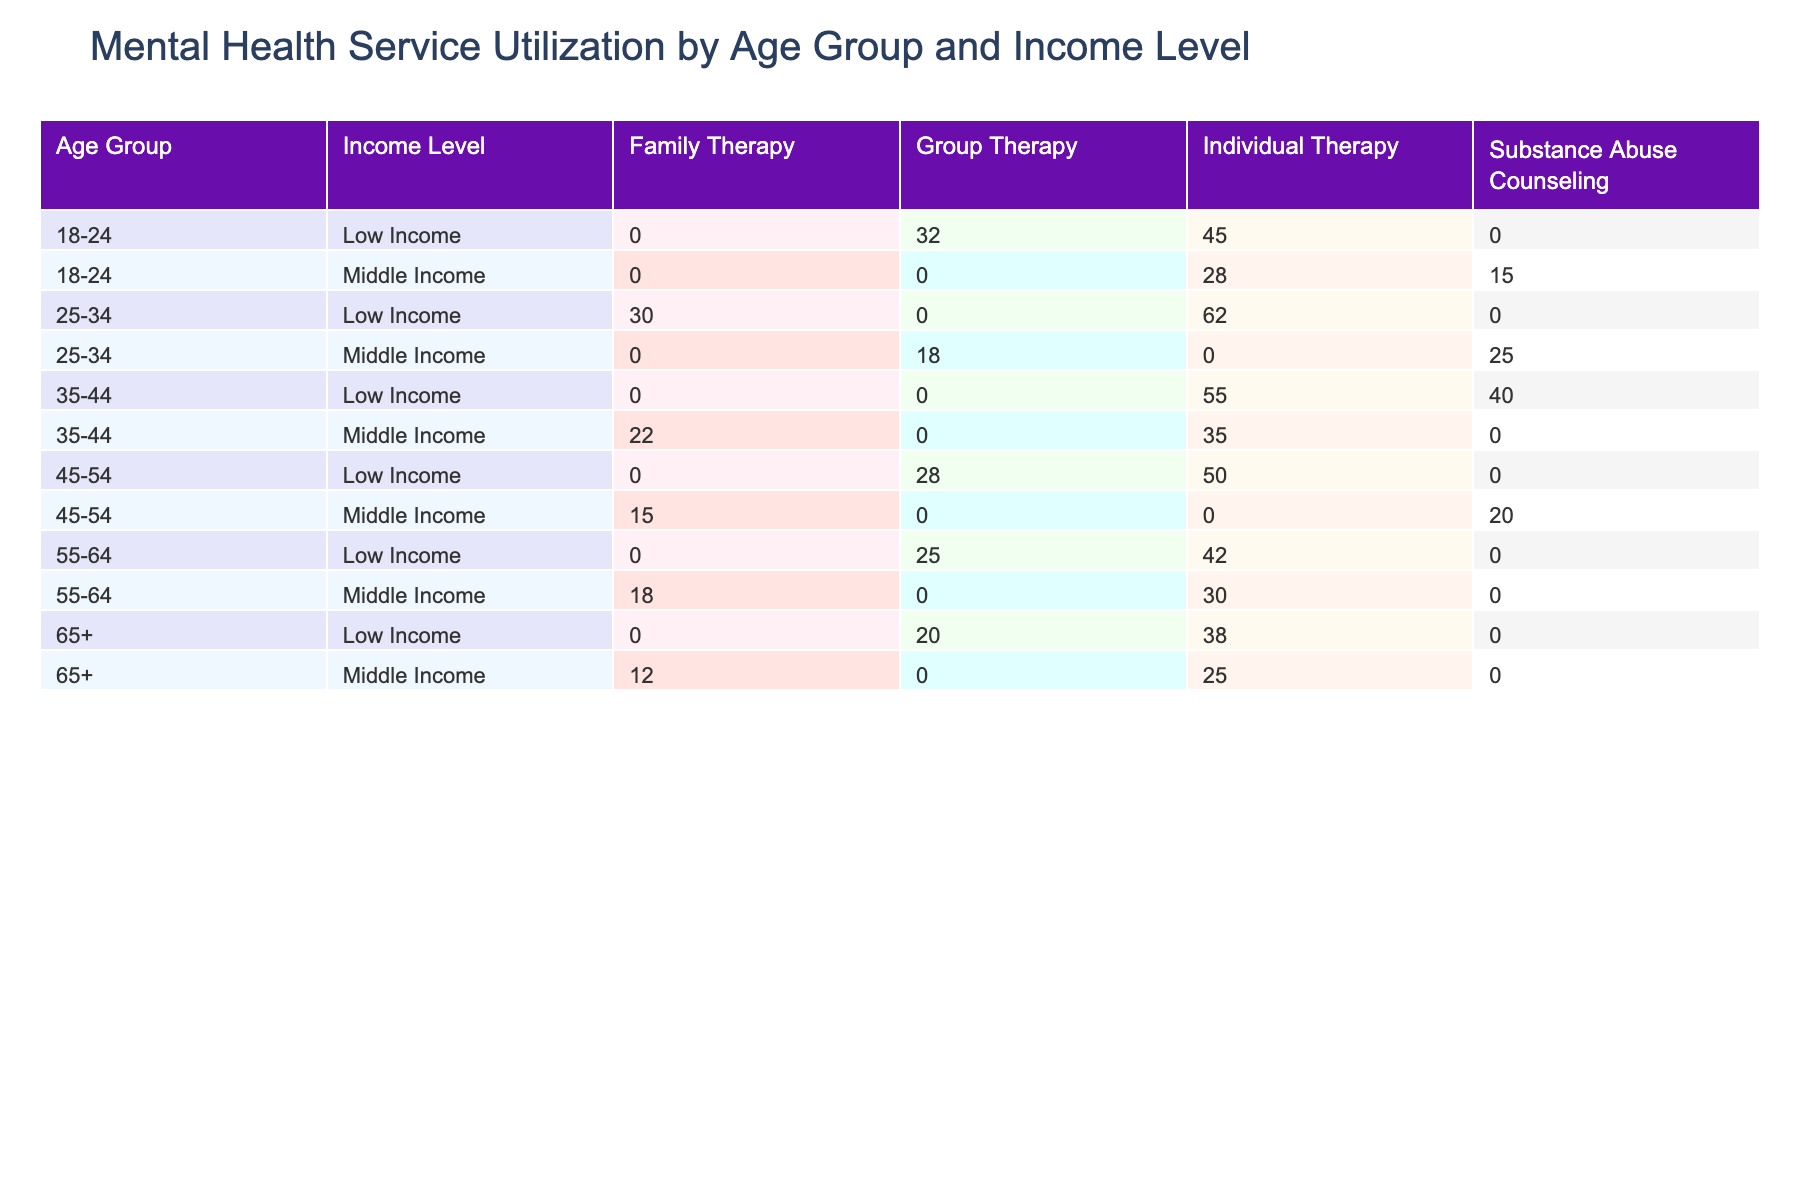What is the total number of visits for Individual Therapy among Low Income patients aged 25-34? To find this, we can look at the "Visit_Count" for the Individual Therapy service under the Low Income category and age group of 25-34. The table shows that there are 62 visits for Individual Therapy for this group.
Answer: 62 What is the average session duration for Group Therapy provided to Middle Income patients? We need to find all the records related to Group Therapy under the Middle Income category. There is one entry with a session duration of 90 minutes when the age group is 25-34 and another entry of 90 minutes when the age group is 45-54. Therefore, the average session duration will be (90 + 90) / 2 = 90.
Answer: 90 Is it true that the patient satisfaction rating for Family Therapy is the same for all income levels? We need to check the patient satisfaction ratings for Family Therapy under different income levels. The ratings are 4.6 for Middle Income and 4.4 for Low Income. Since these ratings are different, the statement is false.
Answer: No Which age group and income level combination has the highest total visit count for Substance Abuse Counseling? We look at the "Visit_Count" for Substance Abuse Counseling across different age groups and income levels. For Low Income, it is 40 visits under the age group 35-44 and for Middle Income, it is 25 visits under the age group 25-34. Thus, the highest total is for Low Income 35-44 with 40 visits.
Answer: 35-44 Low Income What is the difference in patient satisfaction ratings between Individual Therapy for 18-24 Low Income and 35-44 Low Income patients? From the table, the patient satisfaction rating for Individual Therapy for 18-24 Low Income patients is 4.2, and for 35-44 Low Income patients, it is 4.0. The difference is calculated as 4.2 - 4.0 = 0.2.
Answer: 0.2 